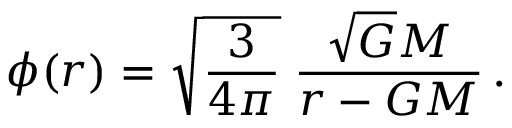Convert formula to latex. <formula><loc_0><loc_0><loc_500><loc_500>\phi ( r ) = \sqrt { \frac { 3 } { 4 \pi } } \, \frac { \sqrt { G } M } { r - G M } \, .</formula> 